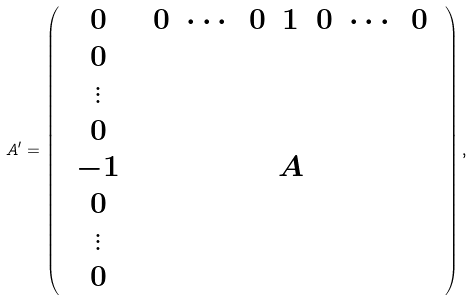Convert formula to latex. <formula><loc_0><loc_0><loc_500><loc_500>A ^ { \prime } = \left ( \begin{array} { c c } 0 & \begin{array} { c c c c c c c } 0 & \cdots & 0 & 1 & 0 & \cdots & 0 \end{array} \\ \begin{array} { c } 0 \\ \vdots \\ 0 \\ - 1 \\ 0 \\ \vdots \\ 0 \end{array} & A \end{array} \right ) ,</formula> 